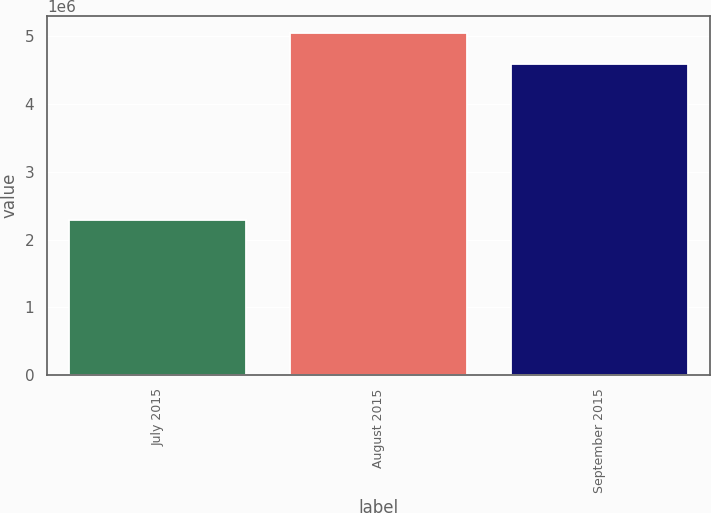Convert chart. <chart><loc_0><loc_0><loc_500><loc_500><bar_chart><fcel>July 2015<fcel>August 2015<fcel>September 2015<nl><fcel>2.29311e+06<fcel>5.04999e+06<fcel>4.59674e+06<nl></chart> 